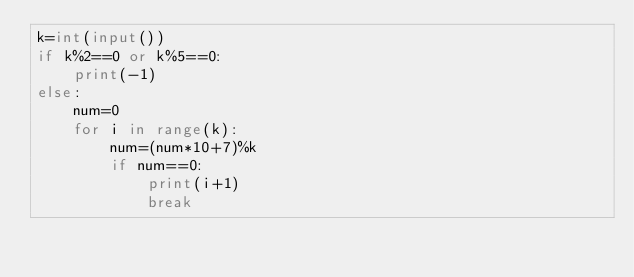<code> <loc_0><loc_0><loc_500><loc_500><_Python_>k=int(input())
if k%2==0 or k%5==0:
    print(-1)
else:
    num=0
    for i in range(k):
        num=(num*10+7)%k
        if num==0:
            print(i+1)
            break
</code> 